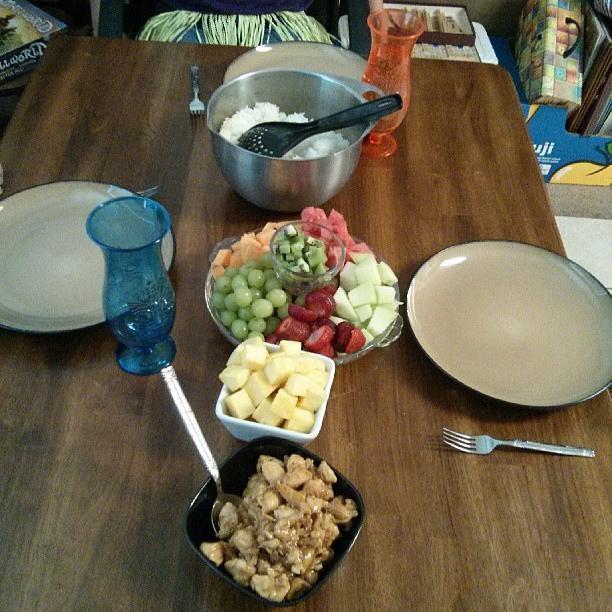How many forks?
Give a very brief answer. 2. How many bowls can be seen?
Give a very brief answer. 5. How many people are on the motorcycle?
Give a very brief answer. 0. 